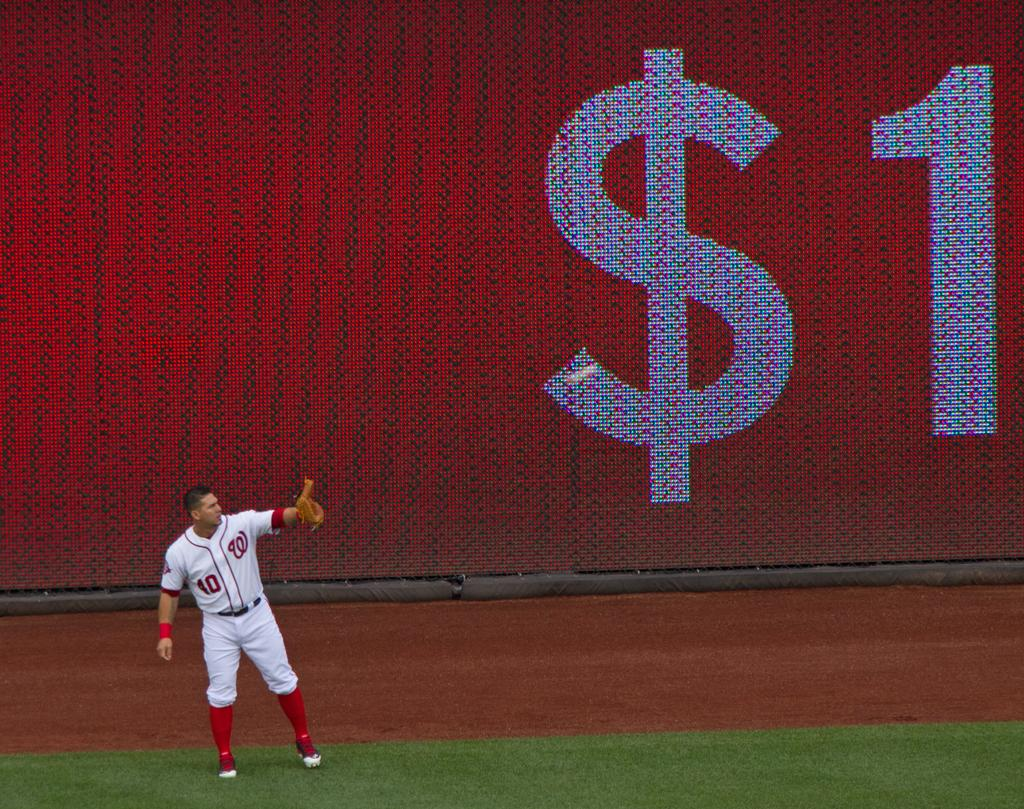<image>
Create a compact narrative representing the image presented. a player that has the letter W on their jersey 